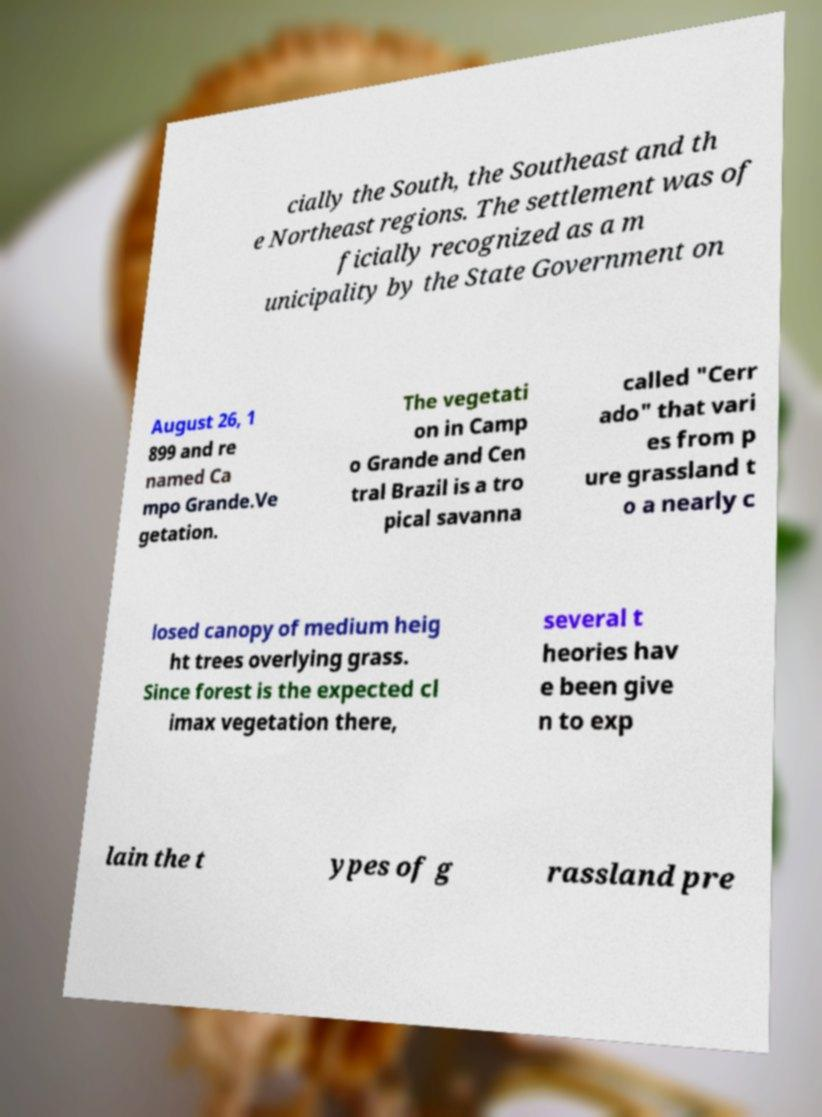For documentation purposes, I need the text within this image transcribed. Could you provide that? cially the South, the Southeast and th e Northeast regions. The settlement was of ficially recognized as a m unicipality by the State Government on August 26, 1 899 and re named Ca mpo Grande.Ve getation. The vegetati on in Camp o Grande and Cen tral Brazil is a tro pical savanna called "Cerr ado" that vari es from p ure grassland t o a nearly c losed canopy of medium heig ht trees overlying grass. Since forest is the expected cl imax vegetation there, several t heories hav e been give n to exp lain the t ypes of g rassland pre 